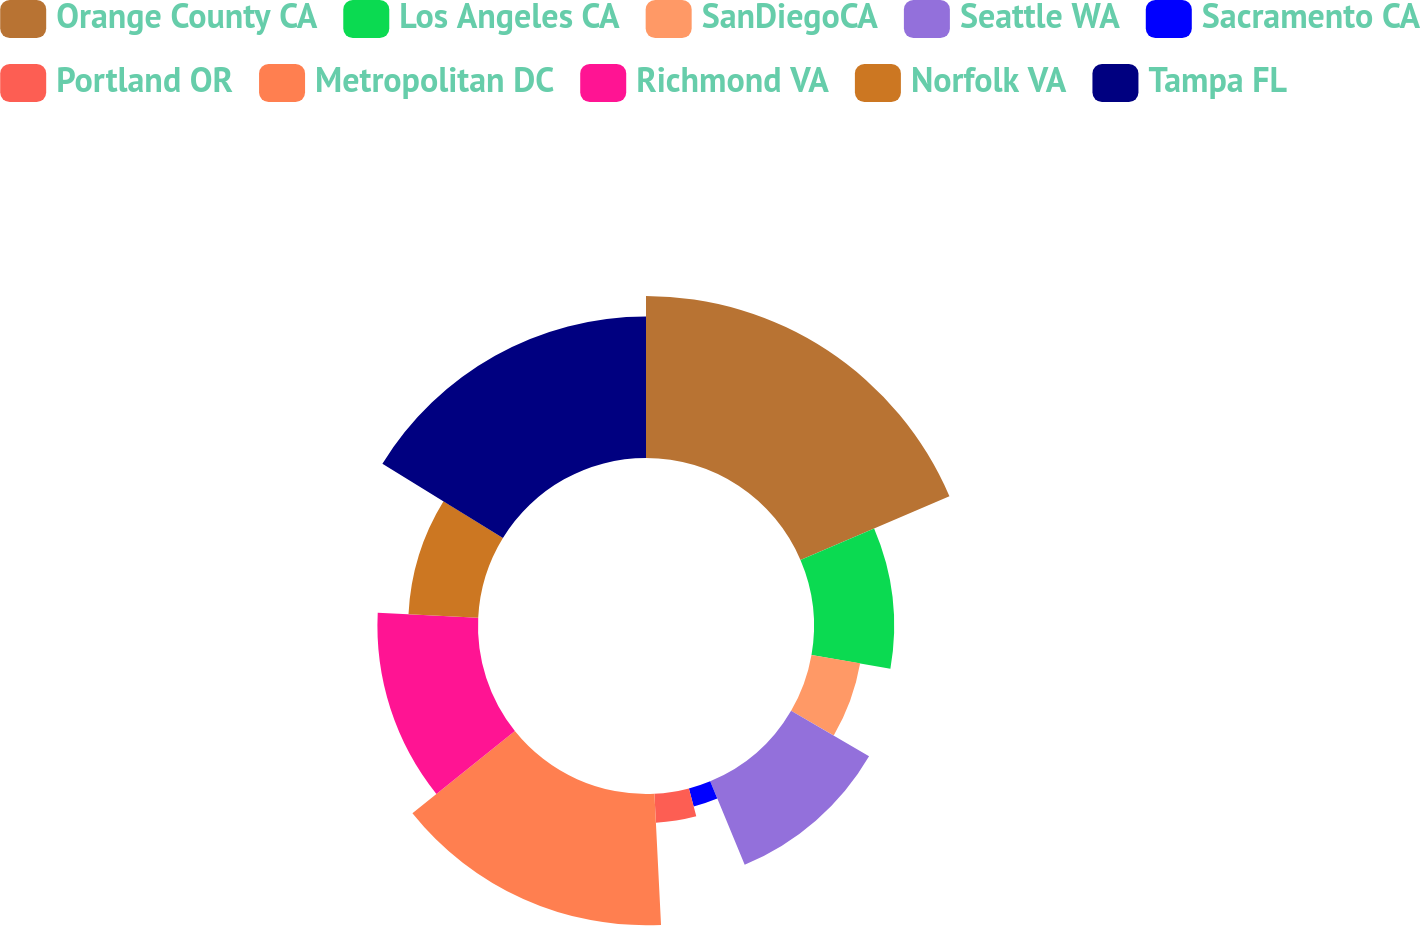<chart> <loc_0><loc_0><loc_500><loc_500><pie_chart><fcel>Orange County CA<fcel>Los Angeles CA<fcel>SanDiegoCA<fcel>Seattle WA<fcel>Sacramento CA<fcel>Portland OR<fcel>Metropolitan DC<fcel>Richmond VA<fcel>Norfolk VA<fcel>Tampa FL<nl><fcel>18.57%<fcel>9.18%<fcel>5.66%<fcel>10.35%<fcel>2.13%<fcel>3.31%<fcel>15.05%<fcel>11.53%<fcel>8.0%<fcel>16.22%<nl></chart> 